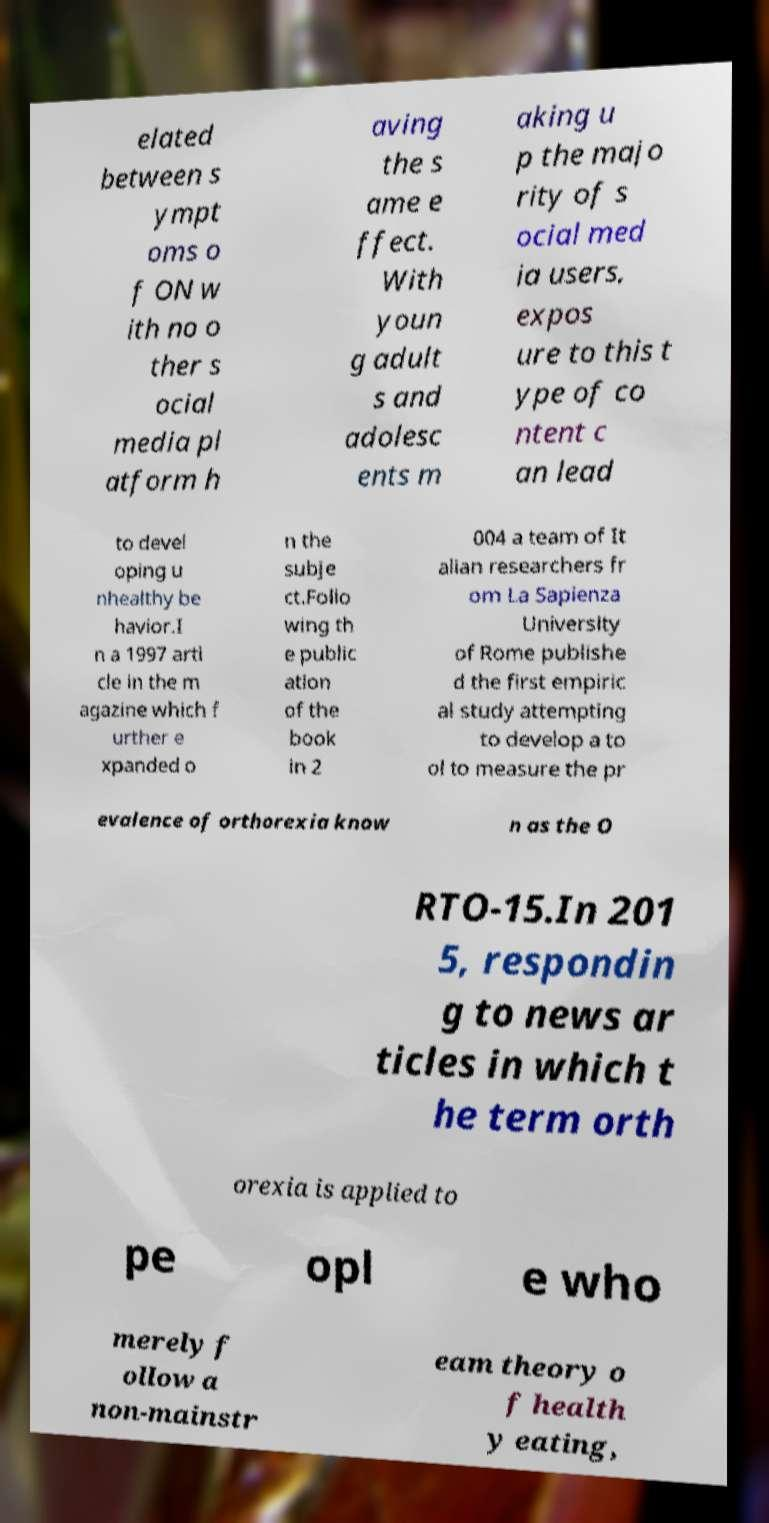There's text embedded in this image that I need extracted. Can you transcribe it verbatim? elated between s ympt oms o f ON w ith no o ther s ocial media pl atform h aving the s ame e ffect. With youn g adult s and adolesc ents m aking u p the majo rity of s ocial med ia users, expos ure to this t ype of co ntent c an lead to devel oping u nhealthy be havior.I n a 1997 arti cle in the m agazine which f urther e xpanded o n the subje ct.Follo wing th e public ation of the book in 2 004 a team of It alian researchers fr om La Sapienza University of Rome publishe d the first empiric al study attempting to develop a to ol to measure the pr evalence of orthorexia know n as the O RTO-15.In 201 5, respondin g to news ar ticles in which t he term orth orexia is applied to pe opl e who merely f ollow a non-mainstr eam theory o f health y eating, 